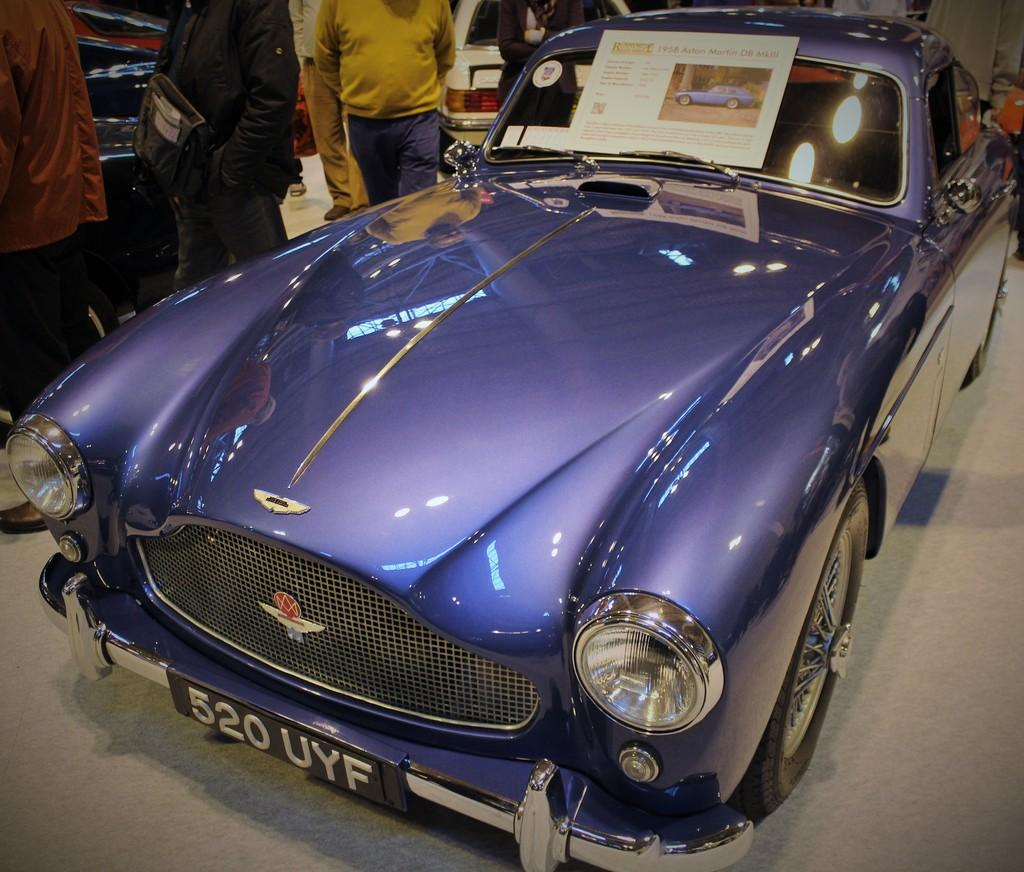What color is the car in the image? The car in the image is violet. Where is the car located in the image? The car is on the road. Are there any people near the car? Yes, there are people standing beside the car. What can be seen above the car in the image? There is a poster above the car. What type of plate is being used to order food in the image? There is no plate or food ordering in the image; it features a violet car on the road with people standing beside it and a poster above it. 